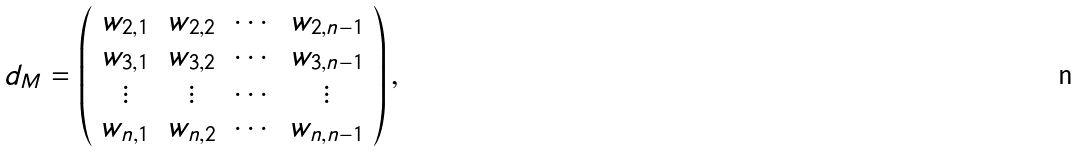Convert formula to latex. <formula><loc_0><loc_0><loc_500><loc_500>d _ { M } = { \left ( \begin{array} { c c c c } w _ { 2 , 1 } & w _ { 2 , 2 } & \cdots & w _ { 2 , n - 1 } \\ w _ { 3 , 1 } & w _ { 3 , 2 } & \cdots & w _ { 3 , n - 1 } \\ \vdots & \vdots & \cdots & \vdots \\ w _ { n , 1 } & w _ { n , 2 } & \cdots & w _ { n , n - 1 } \end{array} \right ) , }</formula> 